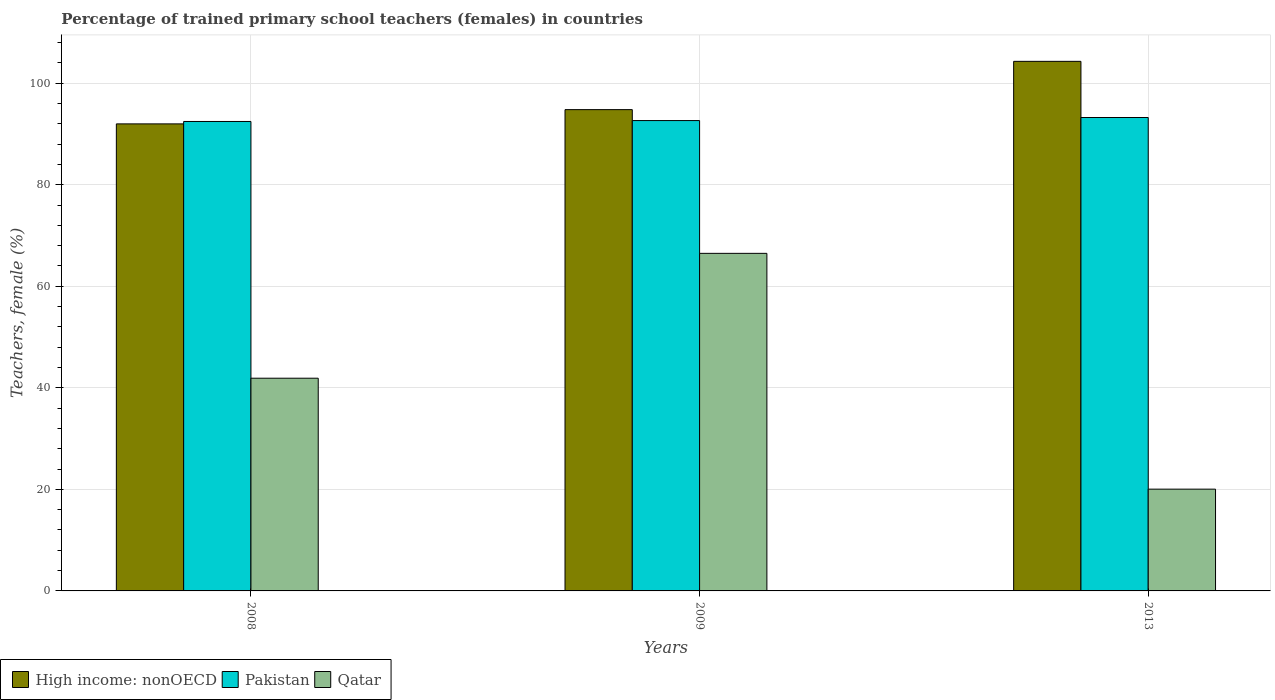Are the number of bars on each tick of the X-axis equal?
Offer a terse response. Yes. How many bars are there on the 3rd tick from the left?
Keep it short and to the point. 3. How many bars are there on the 2nd tick from the right?
Keep it short and to the point. 3. What is the label of the 1st group of bars from the left?
Your answer should be very brief. 2008. What is the percentage of trained primary school teachers (females) in Pakistan in 2008?
Provide a short and direct response. 92.46. Across all years, what is the maximum percentage of trained primary school teachers (females) in Pakistan?
Give a very brief answer. 93.24. Across all years, what is the minimum percentage of trained primary school teachers (females) in Qatar?
Ensure brevity in your answer.  20.04. In which year was the percentage of trained primary school teachers (females) in Qatar maximum?
Offer a terse response. 2009. In which year was the percentage of trained primary school teachers (females) in High income: nonOECD minimum?
Keep it short and to the point. 2008. What is the total percentage of trained primary school teachers (females) in Qatar in the graph?
Give a very brief answer. 128.43. What is the difference between the percentage of trained primary school teachers (females) in High income: nonOECD in 2009 and that in 2013?
Your answer should be very brief. -9.51. What is the difference between the percentage of trained primary school teachers (females) in Pakistan in 2008 and the percentage of trained primary school teachers (females) in Qatar in 2009?
Keep it short and to the point. 25.97. What is the average percentage of trained primary school teachers (females) in Qatar per year?
Give a very brief answer. 42.81. In the year 2013, what is the difference between the percentage of trained primary school teachers (females) in Pakistan and percentage of trained primary school teachers (females) in High income: nonOECD?
Offer a terse response. -11.06. What is the ratio of the percentage of trained primary school teachers (females) in Pakistan in 2008 to that in 2013?
Offer a terse response. 0.99. Is the percentage of trained primary school teachers (females) in Qatar in 2008 less than that in 2009?
Make the answer very short. Yes. What is the difference between the highest and the second highest percentage of trained primary school teachers (females) in Qatar?
Your answer should be compact. 24.59. What is the difference between the highest and the lowest percentage of trained primary school teachers (females) in Qatar?
Provide a succinct answer. 46.44. In how many years, is the percentage of trained primary school teachers (females) in Pakistan greater than the average percentage of trained primary school teachers (females) in Pakistan taken over all years?
Give a very brief answer. 1. What does the 2nd bar from the left in 2009 represents?
Offer a terse response. Pakistan. Are all the bars in the graph horizontal?
Offer a terse response. No. Does the graph contain any zero values?
Make the answer very short. No. How are the legend labels stacked?
Make the answer very short. Horizontal. What is the title of the graph?
Offer a terse response. Percentage of trained primary school teachers (females) in countries. What is the label or title of the X-axis?
Make the answer very short. Years. What is the label or title of the Y-axis?
Keep it short and to the point. Teachers, female (%). What is the Teachers, female (%) in High income: nonOECD in 2008?
Ensure brevity in your answer.  91.99. What is the Teachers, female (%) in Pakistan in 2008?
Make the answer very short. 92.46. What is the Teachers, female (%) in Qatar in 2008?
Make the answer very short. 41.89. What is the Teachers, female (%) of High income: nonOECD in 2009?
Offer a very short reply. 94.79. What is the Teachers, female (%) of Pakistan in 2009?
Give a very brief answer. 92.64. What is the Teachers, female (%) of Qatar in 2009?
Provide a short and direct response. 66.49. What is the Teachers, female (%) in High income: nonOECD in 2013?
Provide a short and direct response. 104.3. What is the Teachers, female (%) of Pakistan in 2013?
Provide a short and direct response. 93.24. What is the Teachers, female (%) of Qatar in 2013?
Your answer should be compact. 20.04. Across all years, what is the maximum Teachers, female (%) of High income: nonOECD?
Give a very brief answer. 104.3. Across all years, what is the maximum Teachers, female (%) in Pakistan?
Give a very brief answer. 93.24. Across all years, what is the maximum Teachers, female (%) of Qatar?
Your answer should be compact. 66.49. Across all years, what is the minimum Teachers, female (%) of High income: nonOECD?
Ensure brevity in your answer.  91.99. Across all years, what is the minimum Teachers, female (%) in Pakistan?
Provide a short and direct response. 92.46. Across all years, what is the minimum Teachers, female (%) in Qatar?
Your response must be concise. 20.04. What is the total Teachers, female (%) in High income: nonOECD in the graph?
Provide a short and direct response. 291.08. What is the total Teachers, female (%) of Pakistan in the graph?
Your answer should be very brief. 278.34. What is the total Teachers, female (%) in Qatar in the graph?
Make the answer very short. 128.43. What is the difference between the Teachers, female (%) of High income: nonOECD in 2008 and that in 2009?
Keep it short and to the point. -2.81. What is the difference between the Teachers, female (%) in Pakistan in 2008 and that in 2009?
Provide a short and direct response. -0.18. What is the difference between the Teachers, female (%) in Qatar in 2008 and that in 2009?
Ensure brevity in your answer.  -24.59. What is the difference between the Teachers, female (%) in High income: nonOECD in 2008 and that in 2013?
Provide a succinct answer. -12.32. What is the difference between the Teachers, female (%) in Pakistan in 2008 and that in 2013?
Your answer should be very brief. -0.78. What is the difference between the Teachers, female (%) of Qatar in 2008 and that in 2013?
Your answer should be compact. 21.85. What is the difference between the Teachers, female (%) of High income: nonOECD in 2009 and that in 2013?
Your answer should be very brief. -9.51. What is the difference between the Teachers, female (%) of Pakistan in 2009 and that in 2013?
Make the answer very short. -0.6. What is the difference between the Teachers, female (%) of Qatar in 2009 and that in 2013?
Give a very brief answer. 46.44. What is the difference between the Teachers, female (%) of High income: nonOECD in 2008 and the Teachers, female (%) of Pakistan in 2009?
Offer a terse response. -0.65. What is the difference between the Teachers, female (%) of High income: nonOECD in 2008 and the Teachers, female (%) of Qatar in 2009?
Provide a short and direct response. 25.5. What is the difference between the Teachers, female (%) of Pakistan in 2008 and the Teachers, female (%) of Qatar in 2009?
Your answer should be compact. 25.97. What is the difference between the Teachers, female (%) of High income: nonOECD in 2008 and the Teachers, female (%) of Pakistan in 2013?
Your response must be concise. -1.26. What is the difference between the Teachers, female (%) of High income: nonOECD in 2008 and the Teachers, female (%) of Qatar in 2013?
Your answer should be compact. 71.94. What is the difference between the Teachers, female (%) in Pakistan in 2008 and the Teachers, female (%) in Qatar in 2013?
Your response must be concise. 72.42. What is the difference between the Teachers, female (%) in High income: nonOECD in 2009 and the Teachers, female (%) in Pakistan in 2013?
Offer a very short reply. 1.55. What is the difference between the Teachers, female (%) in High income: nonOECD in 2009 and the Teachers, female (%) in Qatar in 2013?
Give a very brief answer. 74.75. What is the difference between the Teachers, female (%) in Pakistan in 2009 and the Teachers, female (%) in Qatar in 2013?
Your response must be concise. 72.59. What is the average Teachers, female (%) of High income: nonOECD per year?
Your response must be concise. 97.03. What is the average Teachers, female (%) in Pakistan per year?
Offer a terse response. 92.78. What is the average Teachers, female (%) of Qatar per year?
Give a very brief answer. 42.81. In the year 2008, what is the difference between the Teachers, female (%) of High income: nonOECD and Teachers, female (%) of Pakistan?
Make the answer very short. -0.47. In the year 2008, what is the difference between the Teachers, female (%) in High income: nonOECD and Teachers, female (%) in Qatar?
Provide a succinct answer. 50.09. In the year 2008, what is the difference between the Teachers, female (%) in Pakistan and Teachers, female (%) in Qatar?
Your answer should be compact. 50.57. In the year 2009, what is the difference between the Teachers, female (%) of High income: nonOECD and Teachers, female (%) of Pakistan?
Your response must be concise. 2.16. In the year 2009, what is the difference between the Teachers, female (%) in High income: nonOECD and Teachers, female (%) in Qatar?
Keep it short and to the point. 28.31. In the year 2009, what is the difference between the Teachers, female (%) in Pakistan and Teachers, female (%) in Qatar?
Provide a short and direct response. 26.15. In the year 2013, what is the difference between the Teachers, female (%) in High income: nonOECD and Teachers, female (%) in Pakistan?
Your answer should be compact. 11.06. In the year 2013, what is the difference between the Teachers, female (%) in High income: nonOECD and Teachers, female (%) in Qatar?
Keep it short and to the point. 84.26. In the year 2013, what is the difference between the Teachers, female (%) in Pakistan and Teachers, female (%) in Qatar?
Your answer should be very brief. 73.2. What is the ratio of the Teachers, female (%) in High income: nonOECD in 2008 to that in 2009?
Make the answer very short. 0.97. What is the ratio of the Teachers, female (%) in Qatar in 2008 to that in 2009?
Offer a very short reply. 0.63. What is the ratio of the Teachers, female (%) in High income: nonOECD in 2008 to that in 2013?
Offer a terse response. 0.88. What is the ratio of the Teachers, female (%) of Pakistan in 2008 to that in 2013?
Make the answer very short. 0.99. What is the ratio of the Teachers, female (%) in Qatar in 2008 to that in 2013?
Your response must be concise. 2.09. What is the ratio of the Teachers, female (%) in High income: nonOECD in 2009 to that in 2013?
Give a very brief answer. 0.91. What is the ratio of the Teachers, female (%) of Qatar in 2009 to that in 2013?
Provide a succinct answer. 3.32. What is the difference between the highest and the second highest Teachers, female (%) of High income: nonOECD?
Provide a short and direct response. 9.51. What is the difference between the highest and the second highest Teachers, female (%) in Pakistan?
Your answer should be compact. 0.6. What is the difference between the highest and the second highest Teachers, female (%) in Qatar?
Provide a succinct answer. 24.59. What is the difference between the highest and the lowest Teachers, female (%) of High income: nonOECD?
Offer a terse response. 12.32. What is the difference between the highest and the lowest Teachers, female (%) in Pakistan?
Your answer should be compact. 0.78. What is the difference between the highest and the lowest Teachers, female (%) in Qatar?
Your answer should be very brief. 46.44. 